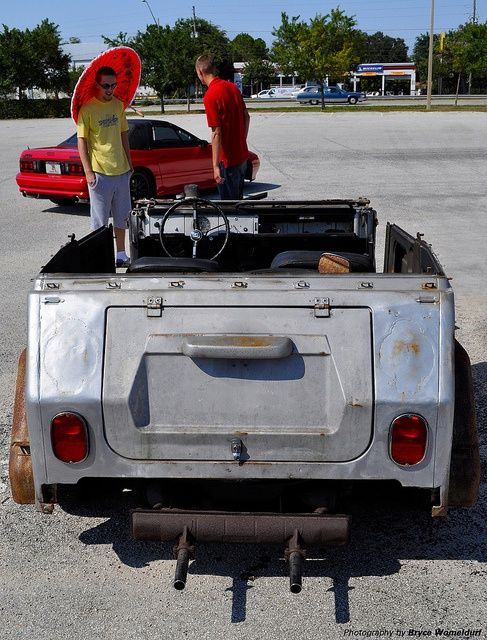Describe the objects in this image and their specific colors. I can see car in lightblue, black, maroon, and brown tones, people in lightblue, olive, gray, maroon, and black tones, people in lightblue, black, maroon, and red tones, umbrella in lightblue, brown, maroon, and black tones, and car in lightblue, navy, black, gray, and blue tones in this image. 